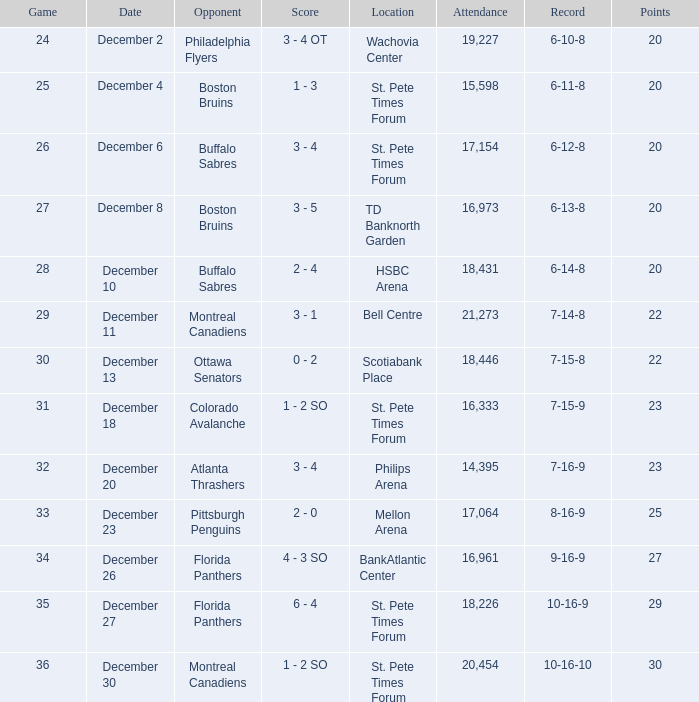Which game possesses a 6-12-8 record? 26.0. 